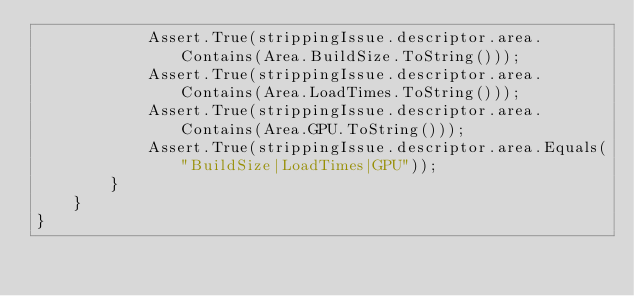Convert code to text. <code><loc_0><loc_0><loc_500><loc_500><_C#_>            Assert.True(strippingIssue.descriptor.area.Contains(Area.BuildSize.ToString()));
            Assert.True(strippingIssue.descriptor.area.Contains(Area.LoadTimes.ToString()));
            Assert.True(strippingIssue.descriptor.area.Contains(Area.GPU.ToString()));
            Assert.True(strippingIssue.descriptor.area.Equals("BuildSize|LoadTimes|GPU"));
        }
    }
}
</code> 